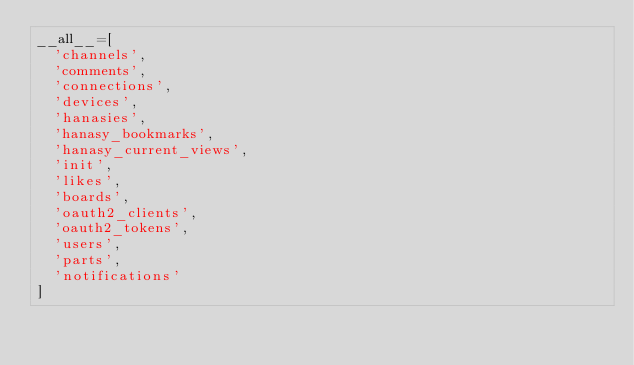<code> <loc_0><loc_0><loc_500><loc_500><_Python_>__all__=[
  'channels',
  'comments',
  'connections',
  'devices',
  'hanasies',
  'hanasy_bookmarks',
  'hanasy_current_views',
  'init',
  'likes',
  'boards',
  'oauth2_clients',
  'oauth2_tokens',
  'users',
  'parts',
  'notifications'
]
</code> 